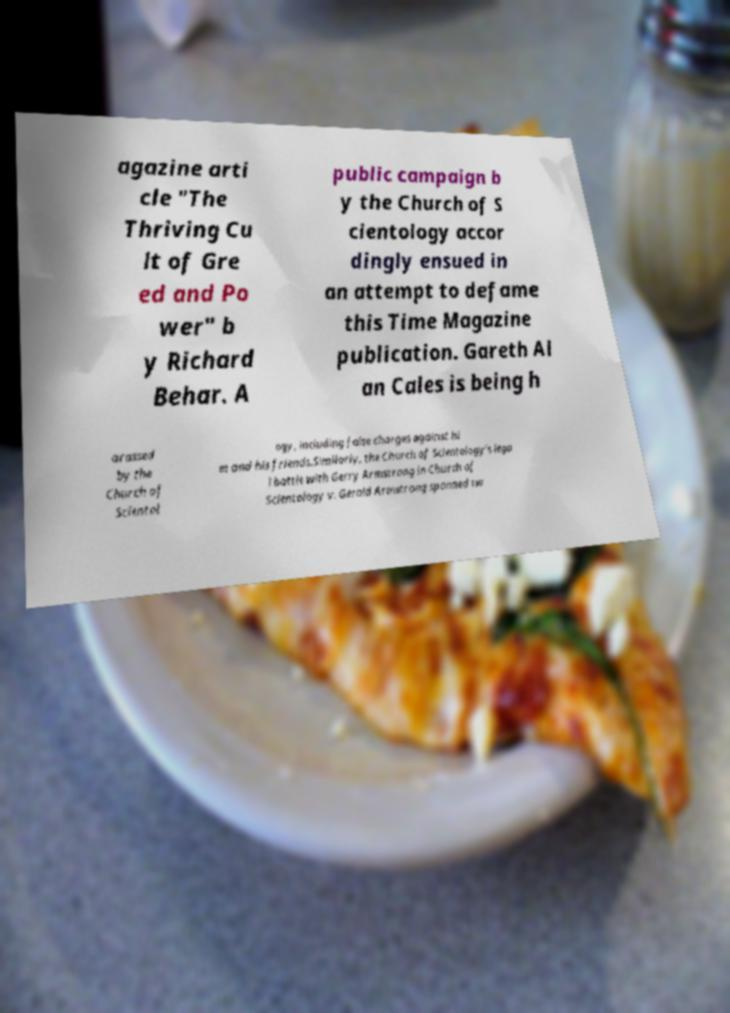Please identify and transcribe the text found in this image. agazine arti cle "The Thriving Cu lt of Gre ed and Po wer" b y Richard Behar. A public campaign b y the Church of S cientology accor dingly ensued in an attempt to defame this Time Magazine publication. Gareth Al an Cales is being h arassed by the Church of Scientol ogy, including false charges against hi m and his friends.Similarly, the Church of Scientology's lega l battle with Gerry Armstrong in Church of Scientology v. Gerald Armstrong spanned tw 